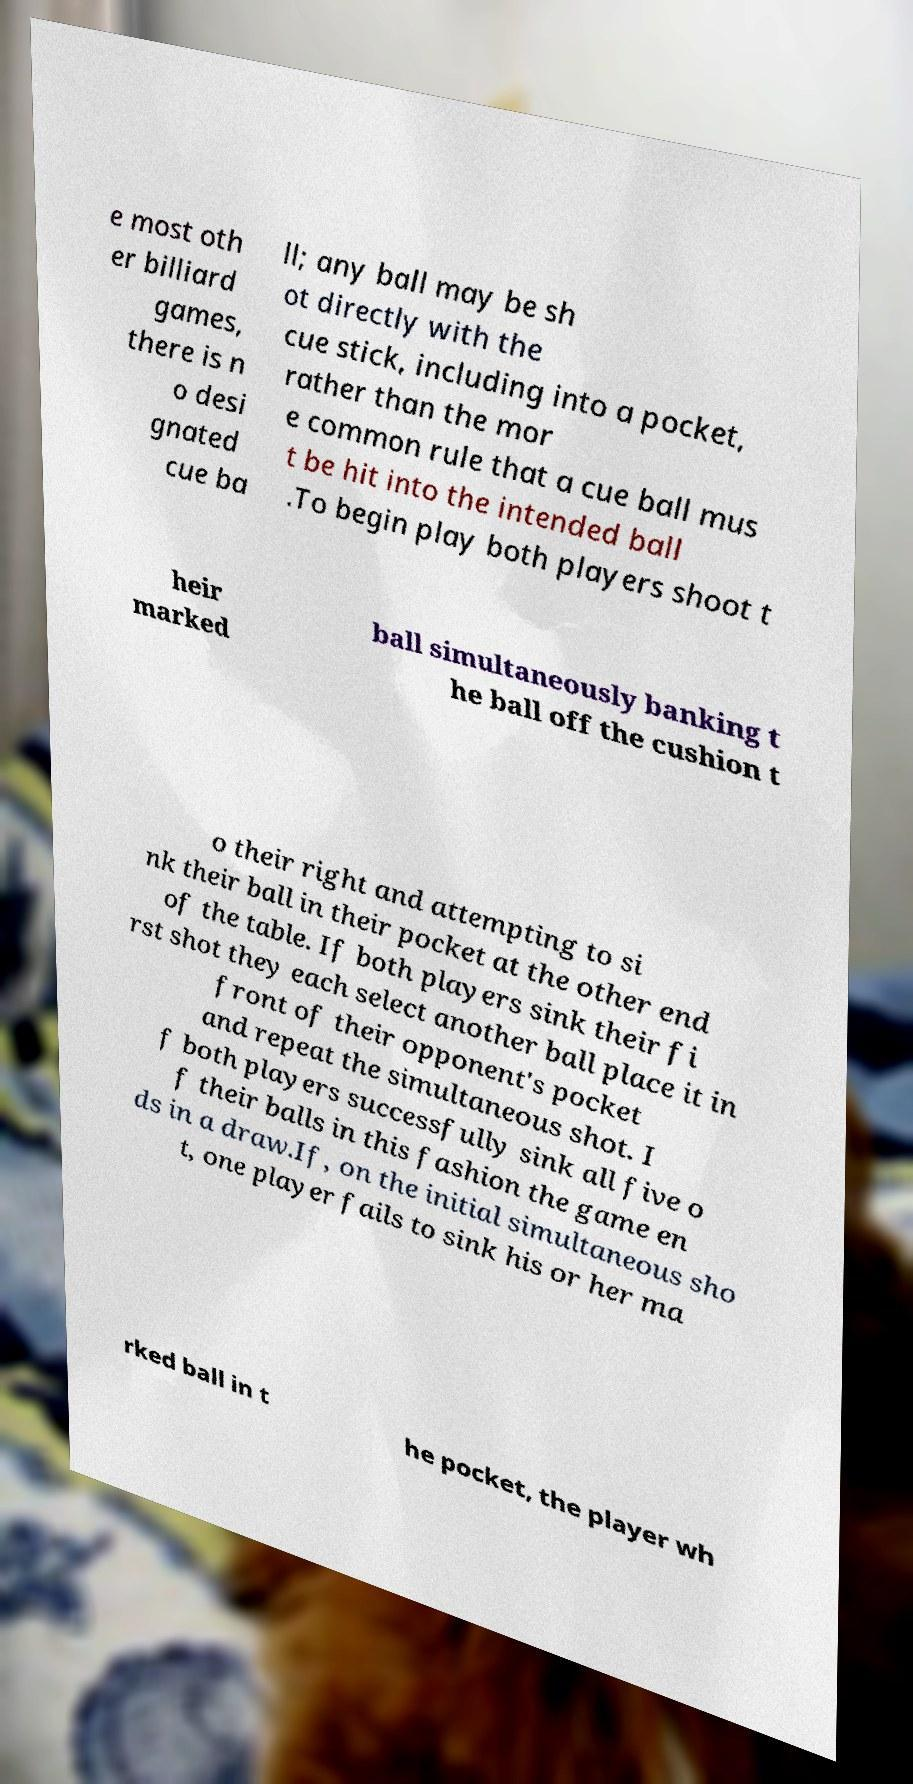Could you assist in decoding the text presented in this image and type it out clearly? e most oth er billiard games, there is n o desi gnated cue ba ll; any ball may be sh ot directly with the cue stick, including into a pocket, rather than the mor e common rule that a cue ball mus t be hit into the intended ball .To begin play both players shoot t heir marked ball simultaneously banking t he ball off the cushion t o their right and attempting to si nk their ball in their pocket at the other end of the table. If both players sink their fi rst shot they each select another ball place it in front of their opponent's pocket and repeat the simultaneous shot. I f both players successfully sink all five o f their balls in this fashion the game en ds in a draw.If, on the initial simultaneous sho t, one player fails to sink his or her ma rked ball in t he pocket, the player wh 